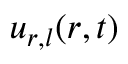<formula> <loc_0><loc_0><loc_500><loc_500>u _ { r , l } ( r , t )</formula> 